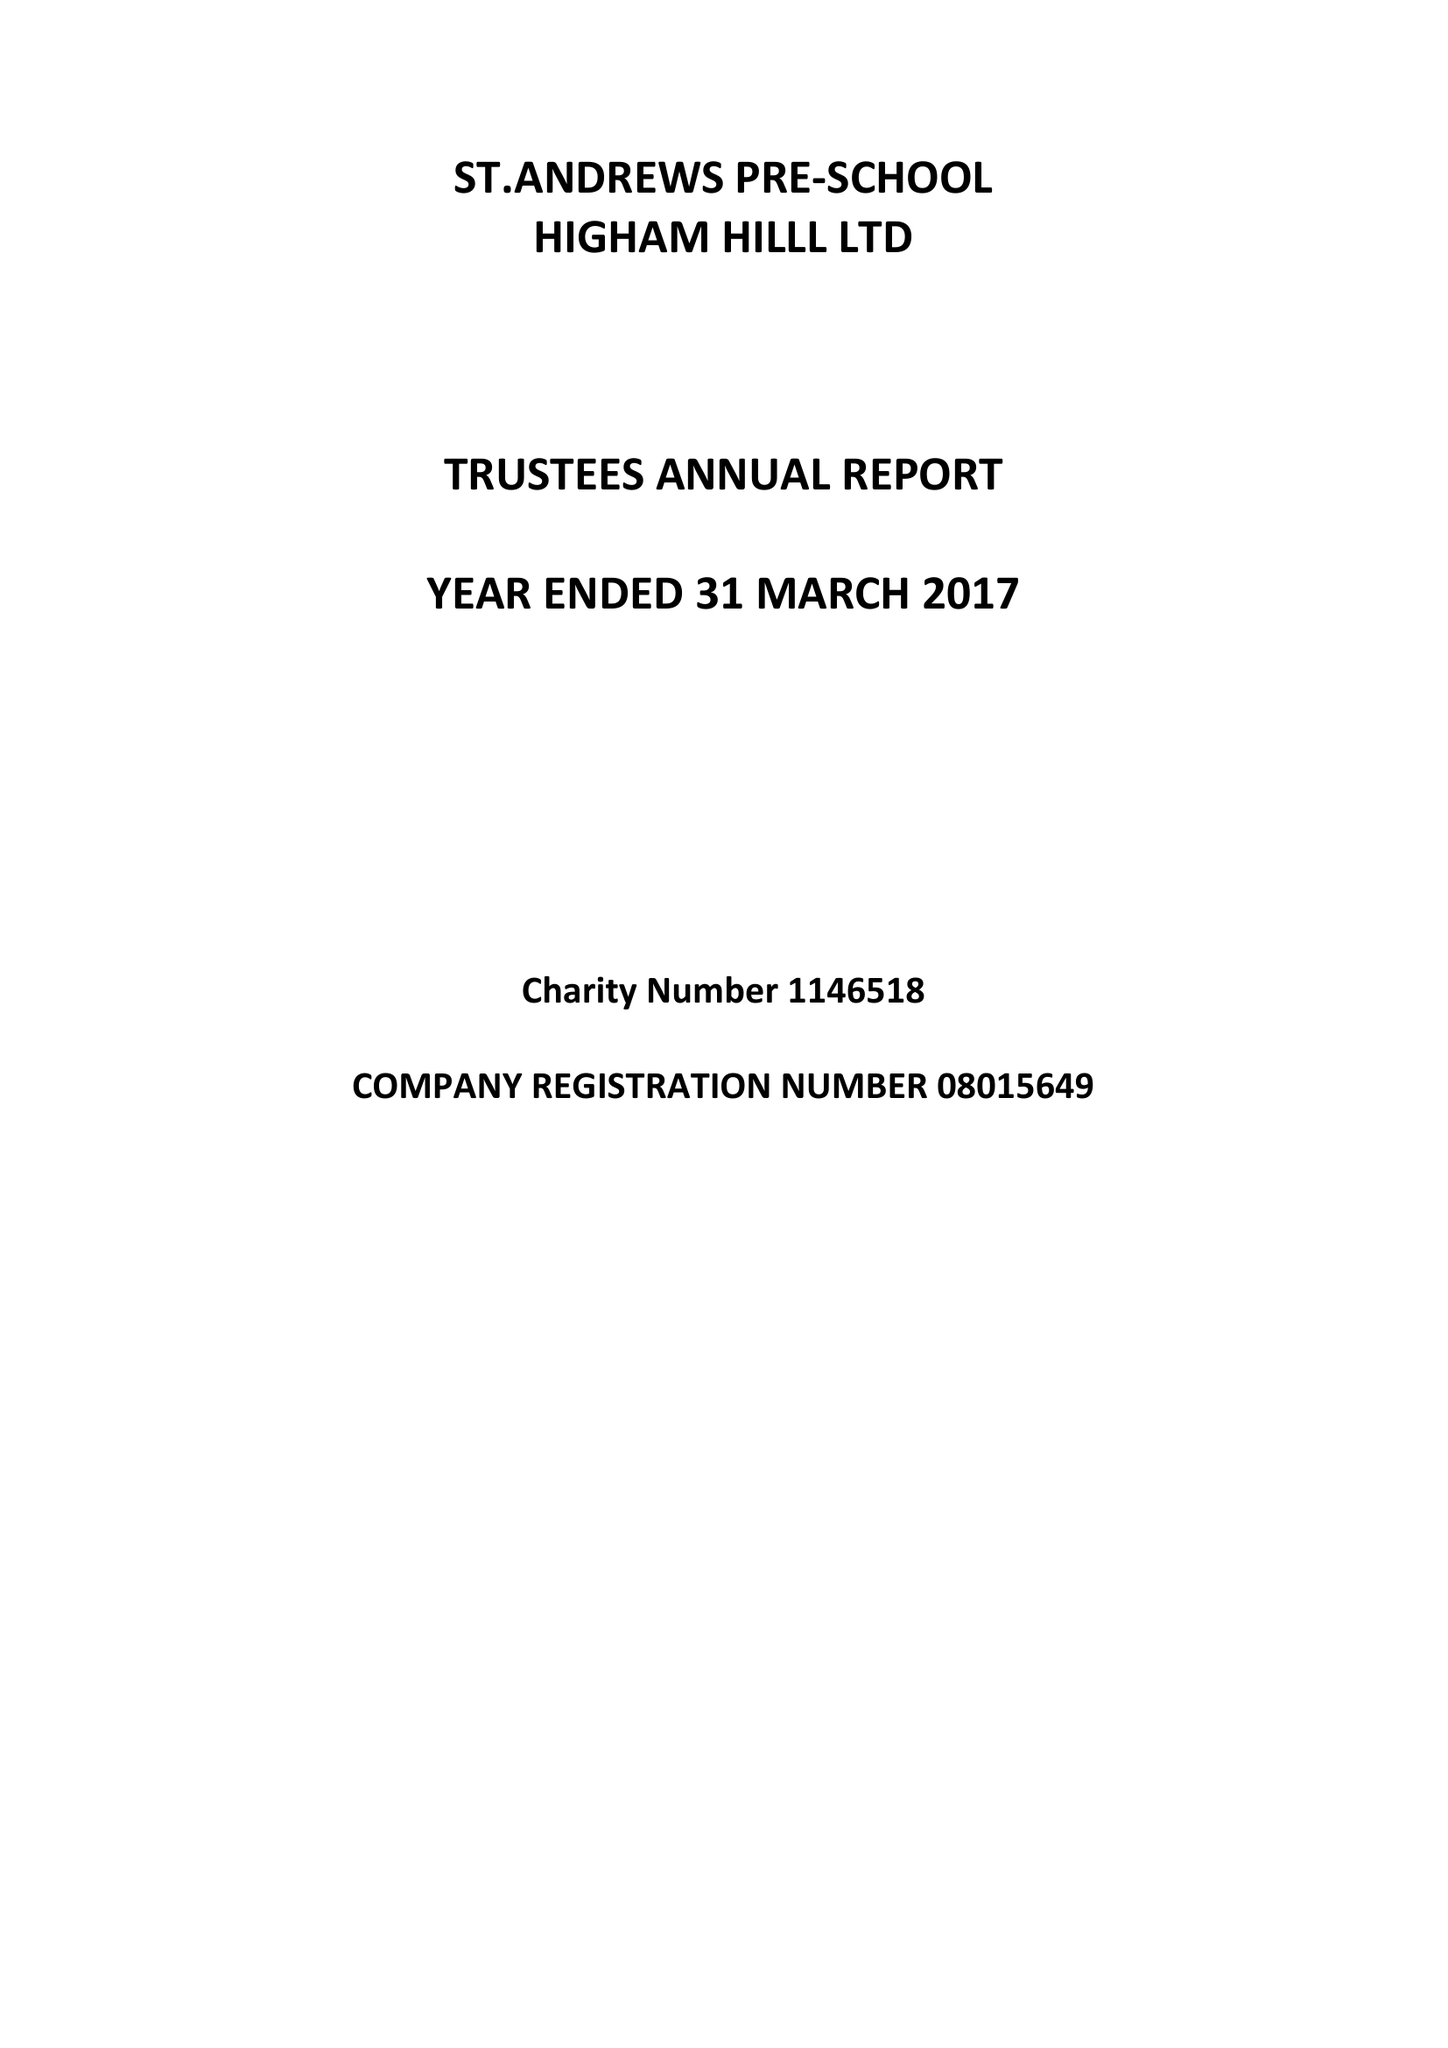What is the value for the report_date?
Answer the question using a single word or phrase. 2017-03-31 